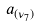<formula> <loc_0><loc_0><loc_500><loc_500>a _ { ( \nu _ { 7 } ) }</formula> 